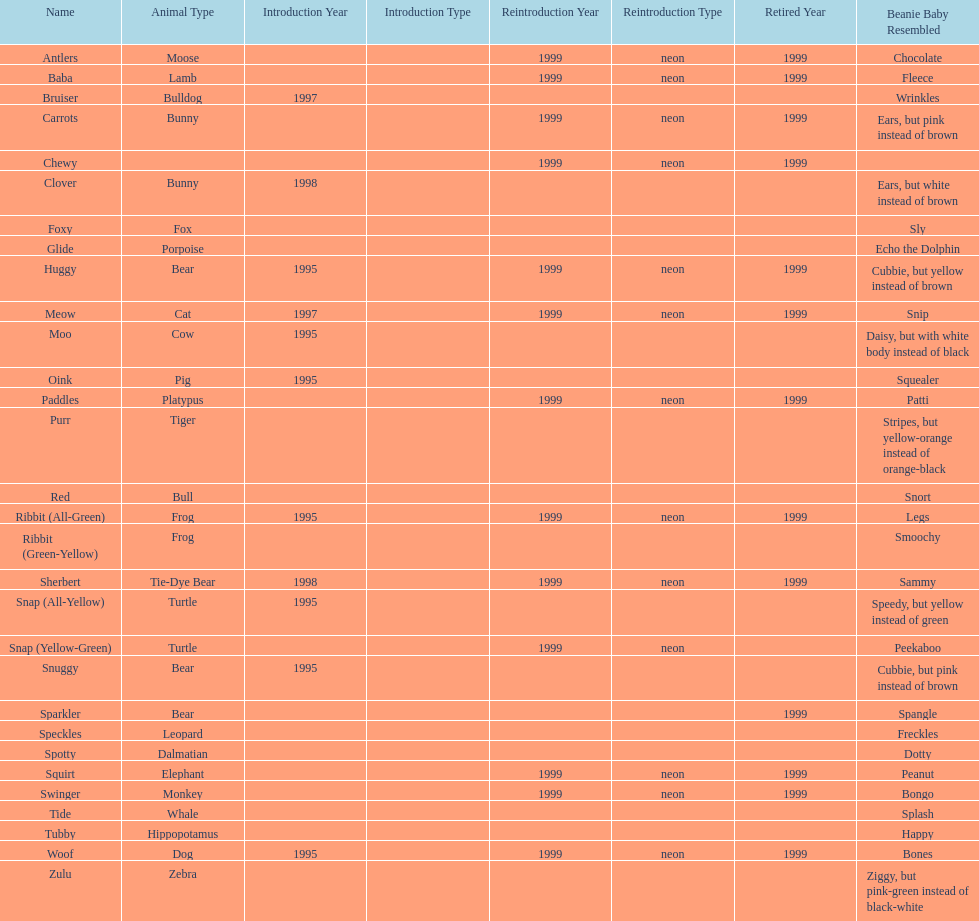Which animal type has the most pillow pals? Bear. 